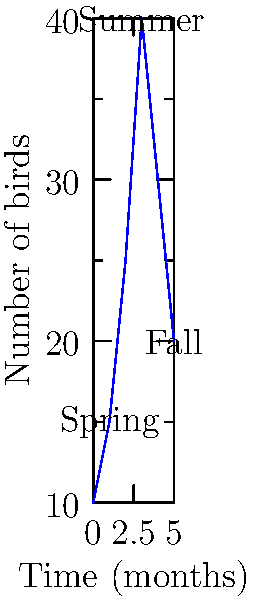Based on the graph showing the spatial distribution of migratory birds in v-formation flight during seasonal transitions, what is the approximate percentage increase in the number of birds from spring to summer? To calculate the percentage increase in the number of birds from spring to summer:

1. Identify the number of birds in spring: approximately 15
2. Identify the number of birds in summer: approximately 40
3. Calculate the difference: 40 - 15 = 25
4. Calculate the percentage increase: (25 / 15) * 100 = 166.67%

Step-by-step calculation:
1. Increase = Summer value - Spring value
   = 40 - 15 = 25
2. Percentage increase = (Increase / Original value) * 100
   = (25 / 15) * 100 = 1.6667 * 100 = 166.67%

Therefore, the approximate percentage increase in the number of birds from spring to summer is 166.67%.
Answer: 166.67% 